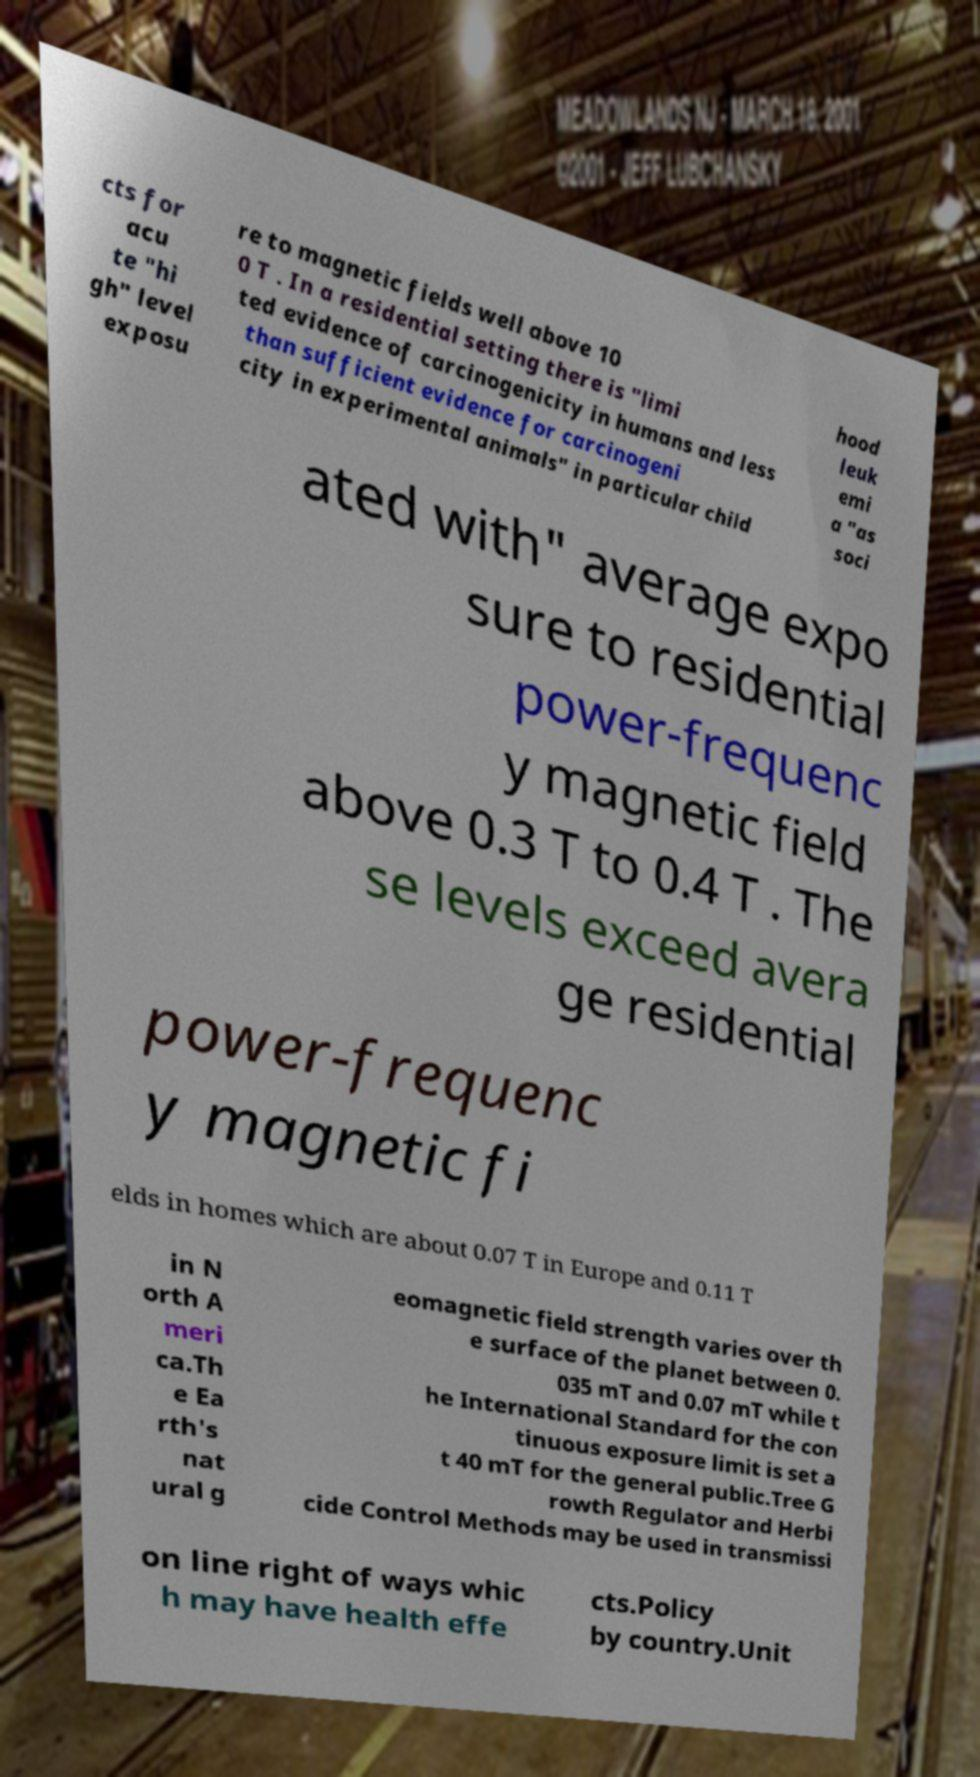There's text embedded in this image that I need extracted. Can you transcribe it verbatim? cts for acu te "hi gh" level exposu re to magnetic fields well above 10 0 T . In a residential setting there is "limi ted evidence of carcinogenicity in humans and less than sufficient evidence for carcinogeni city in experimental animals" in particular child hood leuk emi a "as soci ated with" average expo sure to residential power-frequenc y magnetic field above 0.3 T to 0.4 T . The se levels exceed avera ge residential power-frequenc y magnetic fi elds in homes which are about 0.07 T in Europe and 0.11 T in N orth A meri ca.Th e Ea rth's nat ural g eomagnetic field strength varies over th e surface of the planet between 0. 035 mT and 0.07 mT while t he International Standard for the con tinuous exposure limit is set a t 40 mT for the general public.Tree G rowth Regulator and Herbi cide Control Methods may be used in transmissi on line right of ways whic h may have health effe cts.Policy by country.Unit 